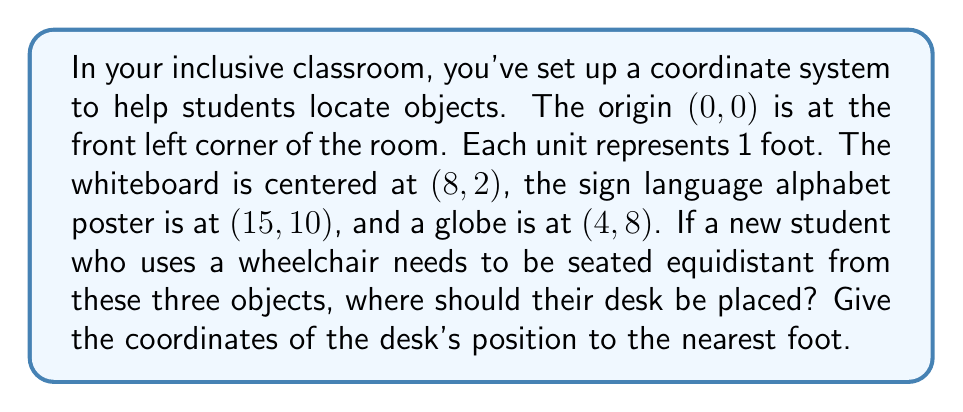Give your solution to this math problem. To find the position equidistant from three points, we need to find the center of the circle that passes through these three points. This point is called the circumcenter. Here's how we can solve this:

1) First, let's identify our three points:
   A (whiteboard): (8,2)
   B (poster): (15,10)
   C (globe): (4,8)

2) To find the circumcenter, we need to find the intersection of the perpendicular bisectors of any two sides of the triangle formed by these points.

3) Let's start by finding the midpoint of AB:
   $M_{AB} = (\frac{8+15}{2}, \frac{2+10}{2}) = (11.5, 6)$

4) The slope of AB is:
   $m_{AB} = \frac{10-2}{15-8} = \frac{8}{7}$

5) The perpendicular slope is the negative reciprocal:
   $m_{\perp AB} = -\frac{7}{8}$

6) Now, let's find the midpoint of BC:
   $M_{BC} = (\frac{15+4}{2}, \frac{10+8}{2}) = (9.5, 9)$

7) The slope of BC is:
   $m_{BC} = \frac{8-10}{4-15} = \frac{2}{11}$

8) The perpendicular slope is:
   $m_{\perp BC} = -\frac{11}{2}$

9) Now we have two lines:
   Line 1: $y - 6 = -\frac{7}{8}(x - 11.5)$
   Line 2: $y - 9 = -\frac{11}{2}(x - 9.5)$

10) Solving these equations simultaneously:
    $-\frac{7}{8}x + 16.0625 = -\frac{11}{2}x + 31.25$
    $\frac{29}{8}x = 15.1875$
    $x = 4.19$

    Substituting back:
    $y = -\frac{7}{8}(4.19 - 11.5) + 6 = 12.39$

11) Rounding to the nearest foot:
    $x = 4$, $y = 12$
Answer: The desk should be placed at coordinates (4,12). 